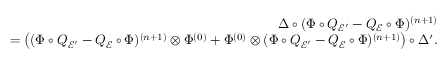<formula> <loc_0><loc_0><loc_500><loc_500>\begin{array} { r } { \Delta \circ ( \Phi \circ Q _ { \mathcal { E } ^ { \prime } } - Q _ { \mathcal { E } } \circ \Phi ) ^ { ( n + 1 ) } } \\ { = \left ( ( \Phi \circ Q _ { \mathcal { E } ^ { \prime } } - Q _ { \mathcal { E } } \circ \Phi ) ^ { ( n + 1 ) } \otimes \Phi ^ { ( 0 ) } + \Phi ^ { ( 0 ) } \otimes ( \Phi \circ Q _ { \mathcal { E } ^ { \prime } } - Q _ { \mathcal { E } } \circ \Phi ) ^ { ( n + 1 ) } \right ) \circ \Delta ^ { \prime } . } \end{array}</formula> 